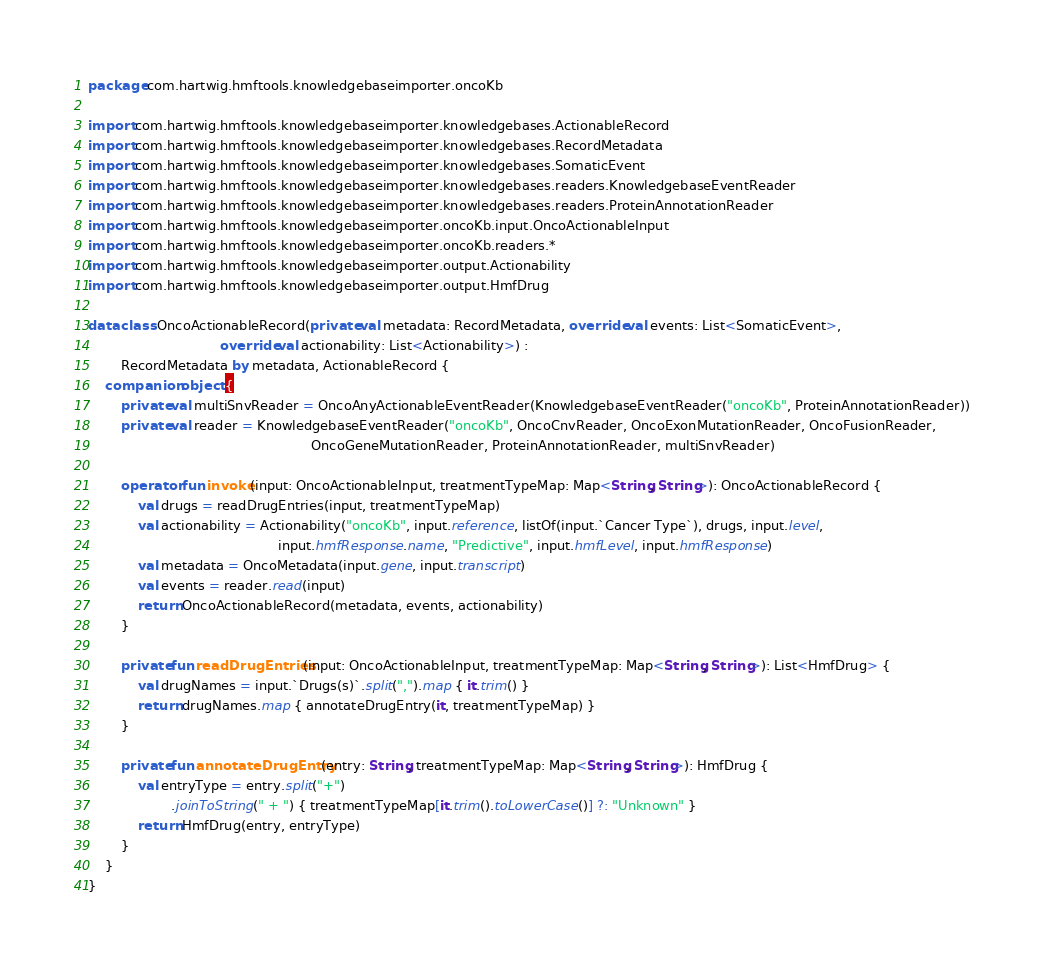<code> <loc_0><loc_0><loc_500><loc_500><_Kotlin_>package com.hartwig.hmftools.knowledgebaseimporter.oncoKb

import com.hartwig.hmftools.knowledgebaseimporter.knowledgebases.ActionableRecord
import com.hartwig.hmftools.knowledgebaseimporter.knowledgebases.RecordMetadata
import com.hartwig.hmftools.knowledgebaseimporter.knowledgebases.SomaticEvent
import com.hartwig.hmftools.knowledgebaseimporter.knowledgebases.readers.KnowledgebaseEventReader
import com.hartwig.hmftools.knowledgebaseimporter.knowledgebases.readers.ProteinAnnotationReader
import com.hartwig.hmftools.knowledgebaseimporter.oncoKb.input.OncoActionableInput
import com.hartwig.hmftools.knowledgebaseimporter.oncoKb.readers.*
import com.hartwig.hmftools.knowledgebaseimporter.output.Actionability
import com.hartwig.hmftools.knowledgebaseimporter.output.HmfDrug

data class OncoActionableRecord(private val metadata: RecordMetadata, override val events: List<SomaticEvent>,
                                override val actionability: List<Actionability>) :
        RecordMetadata by metadata, ActionableRecord {
    companion object {
        private val multiSnvReader = OncoAnyActionableEventReader(KnowledgebaseEventReader("oncoKb", ProteinAnnotationReader))
        private val reader = KnowledgebaseEventReader("oncoKb", OncoCnvReader, OncoExonMutationReader, OncoFusionReader,
                                                      OncoGeneMutationReader, ProteinAnnotationReader, multiSnvReader)

        operator fun invoke(input: OncoActionableInput, treatmentTypeMap: Map<String, String>): OncoActionableRecord {
            val drugs = readDrugEntries(input, treatmentTypeMap)
            val actionability = Actionability("oncoKb", input.reference, listOf(input.`Cancer Type`), drugs, input.level,
                                              input.hmfResponse.name, "Predictive", input.hmfLevel, input.hmfResponse)
            val metadata = OncoMetadata(input.gene, input.transcript)
            val events = reader.read(input)
            return OncoActionableRecord(metadata, events, actionability)
        }

        private fun readDrugEntries(input: OncoActionableInput, treatmentTypeMap: Map<String, String>): List<HmfDrug> {
            val drugNames = input.`Drugs(s)`.split(",").map { it.trim() }
            return drugNames.map { annotateDrugEntry(it, treatmentTypeMap) }
        }

        private fun annotateDrugEntry(entry: String, treatmentTypeMap: Map<String, String>): HmfDrug {
            val entryType = entry.split("+")
                    .joinToString(" + ") { treatmentTypeMap[it.trim().toLowerCase()] ?: "Unknown" }
            return HmfDrug(entry, entryType)
        }
    }
}
</code> 